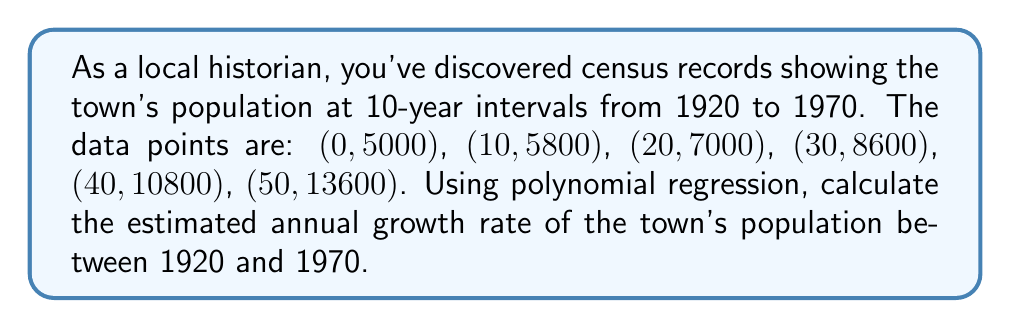Provide a solution to this math problem. 1) First, we need to determine the degree of the polynomial that best fits the data. Given the shape of the data, a quadratic polynomial (degree 2) should suffice.

2) The general form of a quadratic polynomial is:
   $$P(x) = ax^2 + bx + c$$

3) We'll use the least squares method to find the coefficients a, b, and c. This involves solving the normal equations:

   $$\begin{bmatrix}
   \sum x^4 & \sum x^3 & \sum x^2 \\
   \sum x^3 & \sum x^2 & \sum x \\
   \sum x^2 & \sum x & n
   \end{bmatrix}
   \begin{bmatrix}
   a \\ b \\ c
   \end{bmatrix} =
   \begin{bmatrix}
   \sum yx^2 \\ \sum yx \\ \sum y
   \end{bmatrix}$$

4) Calculating the sums:
   $\sum x^4 = 1,625,000$
   $\sum x^3 = 162,500$
   $\sum x^2 = 8,750$
   $\sum x = 150$
   $n = 6$
   $\sum yx^2 = 18,550,000$
   $\sum yx = 1,160,000$
   $\sum y = 50,800$

5) Solving the system of equations:
   $$\begin{bmatrix}
   1625000 & 162500 & 8750 \\
   162500 & 8750 & 150 \\
   8750 & 150 & 6
   \end{bmatrix}
   \begin{bmatrix}
   a \\ b \\ c
   \end{bmatrix} =
   \begin{bmatrix}
   18550000 \\ 1160000 \\ 50800
   \end{bmatrix}$$

6) The solution gives us:
   $a \approx 1.2$
   $b \approx 72$
   $c \approx 5000$

7) Our polynomial is thus:
   $$P(x) = 1.2x^2 + 72x + 5000$$

8) To find the growth rate, we need to calculate the average annual increase:
   $$\frac{P(50) - P(0)}{50} = \frac{13600 - 5000}{50} = 172$$

9) The average annual growth rate is:
   $$\frac{172}{5000} \times 100\% \approx 3.44\%$$
Answer: 3.44% per year 